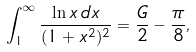Convert formula to latex. <formula><loc_0><loc_0><loc_500><loc_500>\int _ { 1 } ^ { \infty } \frac { \ln x \, d x } { ( 1 + x ^ { 2 } ) ^ { 2 } } = \frac { G } { 2 } - \frac { \pi } { 8 } ,</formula> 